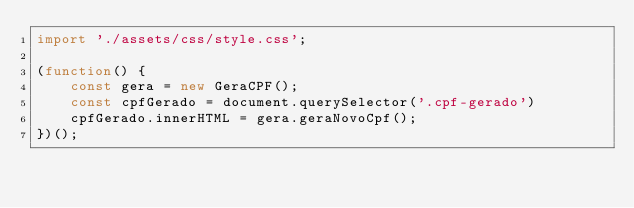<code> <loc_0><loc_0><loc_500><loc_500><_JavaScript_>import './assets/css/style.css';

(function() {
    const gera = new GeraCPF();
    const cpfGerado = document.querySelector('.cpf-gerado')
    cpfGerado.innerHTML = gera.geraNovoCpf();
})();</code> 